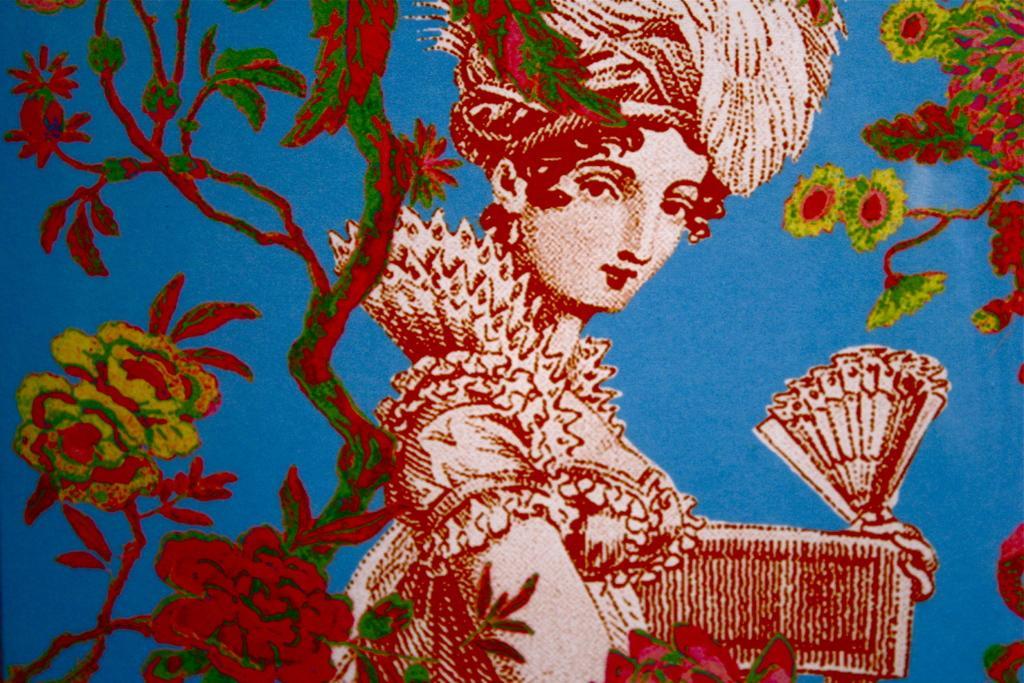Can you describe this image briefly? This image consists of an art. In this image we can see a woman carrying a rigid fan in her hands. The background is blue in color. On the left and right sides of the image there is an art of a plant with leaves, stems and flowers. 